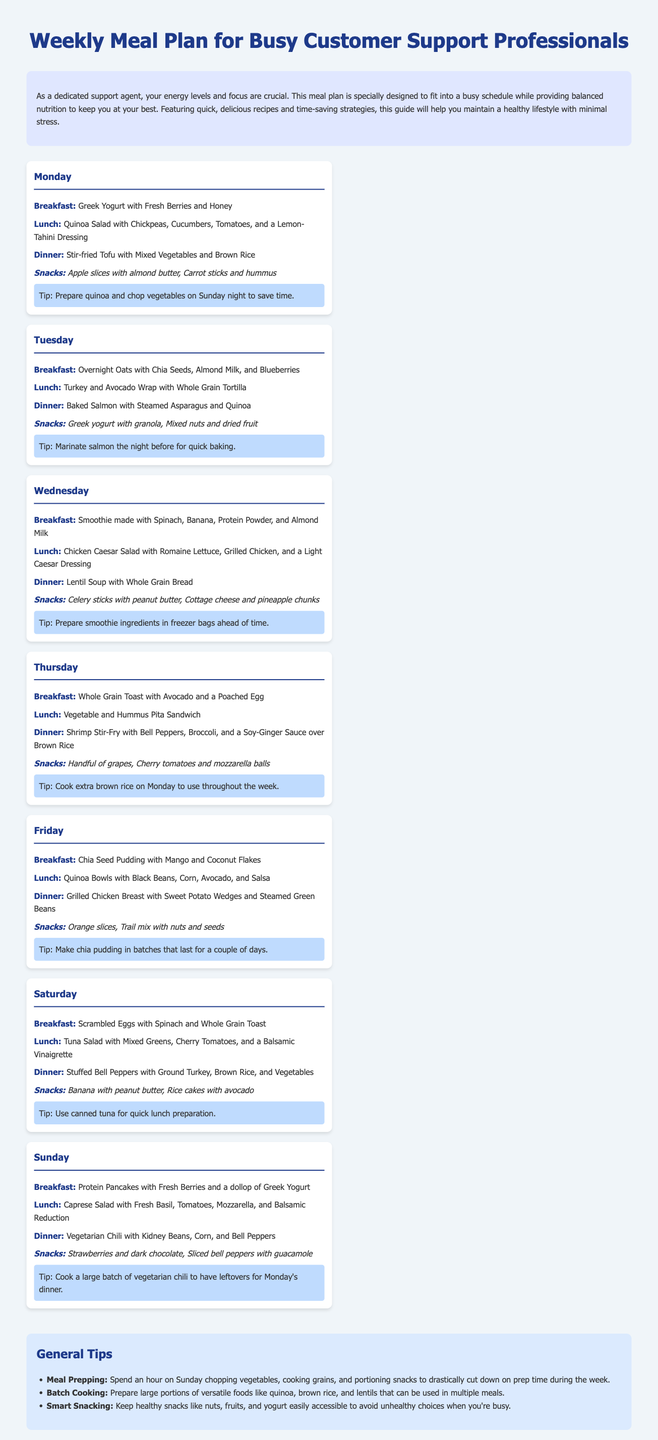What is the breakfast for Monday? The breakfast for Monday is Greek Yogurt with Fresh Berries and Honey, which is directly listed in the meal plan.
Answer: Greek Yogurt with Fresh Berries and Honey How many meals are suggested for each day? Each day's plan includes four meals: breakfast, lunch, dinner, and snacks, as seen in the structure of the document.
Answer: Four meals What is the suggested snack for Tuesday? The snack for Tuesday is Greek yogurt with granola and mixed nuts with dried fruit, as listed under the Tuesday meal plan.
Answer: Greek yogurt with granola, Mixed nuts and dried fruit Which day features a Vegetable and Hummus Pita Sandwich for lunch? The lunch option of a Vegetable and Hummus Pita Sandwich is specifically mentioned for Thursday.
Answer: Thursday On which day is Chia Seed Pudding served for breakfast? Chia Seed Pudding is mentioned for breakfast on Friday in the meal plan.
Answer: Friday What tip is provided for Monday's meal preparation? The tip for Monday suggests preparing quinoa and chopping vegetables on Sunday night. This is directly stated in the tip section for Monday.
Answer: Prepare quinoa and chop vegetables on Sunday night What type of salad is featured for lunch on Sunday? Sunday's lunch features a Caprese Salad with Fresh Basil, Tomatoes, Mozzarella, and Balsamic Reduction, which is explicitly listed in the plan.
Answer: Caprese Salad What is the main protein source for the dinner meal on Tuesday? The dinner meal on Tuesday is Baked Salmon, indicating salmon is the main protein source that night.
Answer: Salmon Which meal plan day includes a vegetarian chili for dinner? Vegetarian Chili is the dinner option for Sunday, as per the meal plan details.
Answer: Sunday 